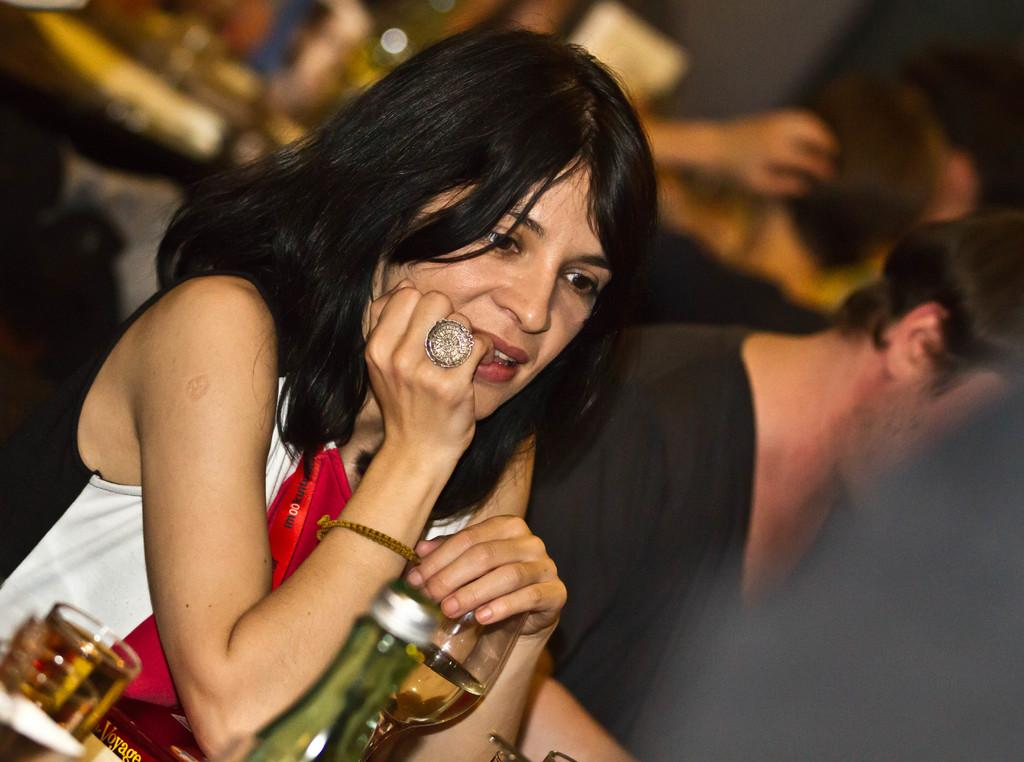Who is present in the image? There is a lady in the image. What accessories is the lady wearing? The lady is wearing a ring and a bracelet. What is the lady holding in the image? The lady is holding a glass. Are there any other objects related to the glass in the image? Yes, there is a glass and a bottle in front of the lady. Can you describe the person in the background of the image? The person in the background is blurred, so it is difficult to provide any specific details. What type of steel is used to make the lady's tail in the image? There is no tail present on the lady in the image, so the type of steel used for it cannot be determined. 